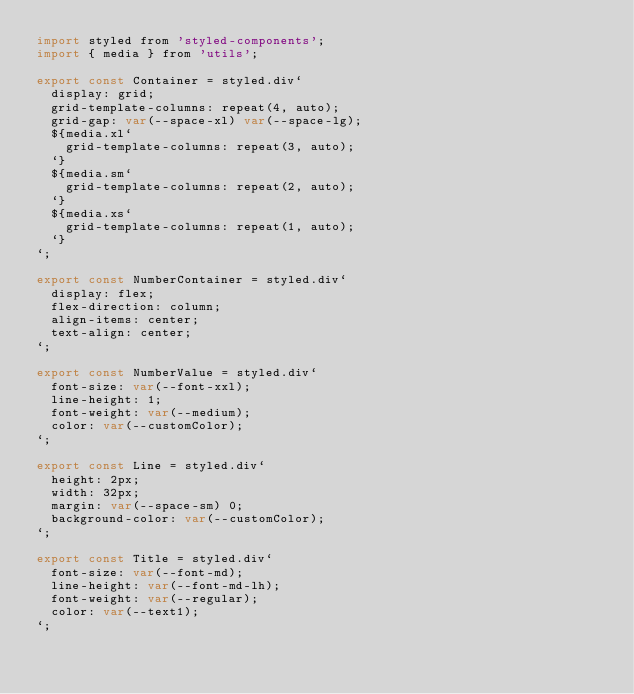<code> <loc_0><loc_0><loc_500><loc_500><_JavaScript_>import styled from 'styled-components';
import { media } from 'utils';

export const Container = styled.div`
  display: grid;
  grid-template-columns: repeat(4, auto);
  grid-gap: var(--space-xl) var(--space-lg);
  ${media.xl`
    grid-template-columns: repeat(3, auto);
  `}
  ${media.sm`
    grid-template-columns: repeat(2, auto);
  `}
  ${media.xs`
    grid-template-columns: repeat(1, auto);
  `}
`;

export const NumberContainer = styled.div`
  display: flex;
  flex-direction: column;
  align-items: center;
  text-align: center;
`;

export const NumberValue = styled.div`
  font-size: var(--font-xxl);
  line-height: 1;
  font-weight: var(--medium);
  color: var(--customColor);
`;

export const Line = styled.div`
  height: 2px;
  width: 32px;
  margin: var(--space-sm) 0;
  background-color: var(--customColor);
`;

export const Title = styled.div`
  font-size: var(--font-md);
  line-height: var(--font-md-lh);
  font-weight: var(--regular);
  color: var(--text1);
`;
</code> 